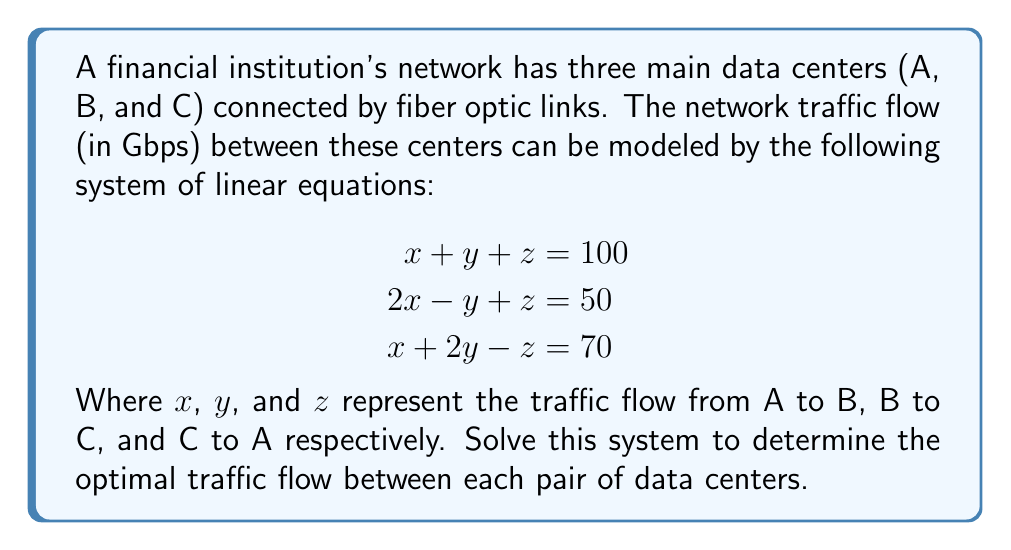Provide a solution to this math problem. Let's solve this system of linear equations using the elimination method:

1) First, let's eliminate $z$ by adding equations (1) and (2):

   $$\begin{aligned}
   (x + y + z) + (2x - y + z) &= 100 + 50 \\
   3x + 150 &= 150
   \end{aligned}$$

2) Simplify:
   $$3x = 0$$
   $$x = 0$$

3) Now, substitute $x = 0$ into equation (1):
   $$y + z = 100$$

4) And into equation (3):
   $$2y - z = 70$$

5) Now we have a system of two equations with two unknowns:
   $$\begin{aligned}
   y + z &= 100 \\
   2y - z &= 70
   \end{aligned}$$

6) Add these equations to eliminate $z$:
   $$3y = 170$$
   $$y = \frac{170}{3} \approx 56.67$$

7) Substitute this value of $y$ back into $y + z = 100$:
   $$56.67 + z = 100$$
   $$z = 43.33$$

8) Therefore, the solution is:
   $$x = 0, y \approx 56.67, z \approx 43.33$$
Answer: A to B: 0 Gbps, B to C: 56.67 Gbps, C to A: 43.33 Gbps 